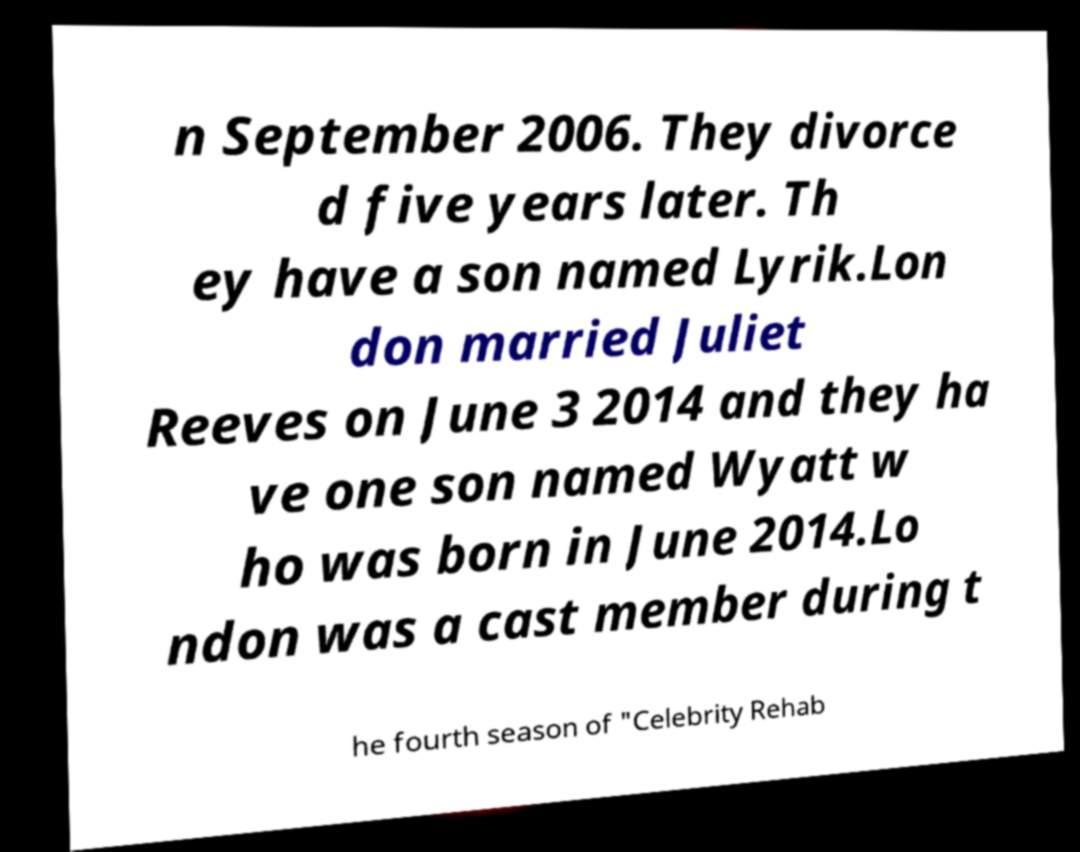Can you read and provide the text displayed in the image?This photo seems to have some interesting text. Can you extract and type it out for me? n September 2006. They divorce d five years later. Th ey have a son named Lyrik.Lon don married Juliet Reeves on June 3 2014 and they ha ve one son named Wyatt w ho was born in June 2014.Lo ndon was a cast member during t he fourth season of "Celebrity Rehab 